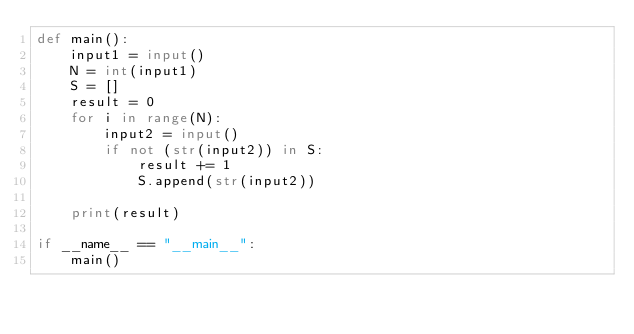<code> <loc_0><loc_0><loc_500><loc_500><_Python_>def main():
    input1 = input()
    N = int(input1)
    S = []
    result = 0
    for i in range(N):
        input2 = input()
        if not (str(input2)) in S:
            result += 1
            S.append(str(input2))
    
    print(result)

if __name__ == "__main__":
    main()</code> 